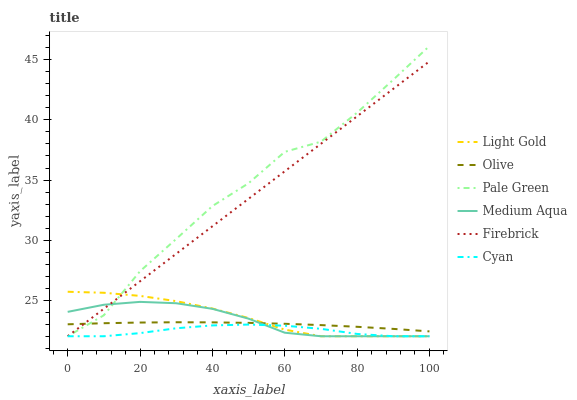Does Medium Aqua have the minimum area under the curve?
Answer yes or no. No. Does Medium Aqua have the maximum area under the curve?
Answer yes or no. No. Is Medium Aqua the smoothest?
Answer yes or no. No. Is Medium Aqua the roughest?
Answer yes or no. No. Does Olive have the lowest value?
Answer yes or no. No. Does Medium Aqua have the highest value?
Answer yes or no. No. Is Cyan less than Olive?
Answer yes or no. Yes. Is Olive greater than Cyan?
Answer yes or no. Yes. Does Cyan intersect Olive?
Answer yes or no. No. 